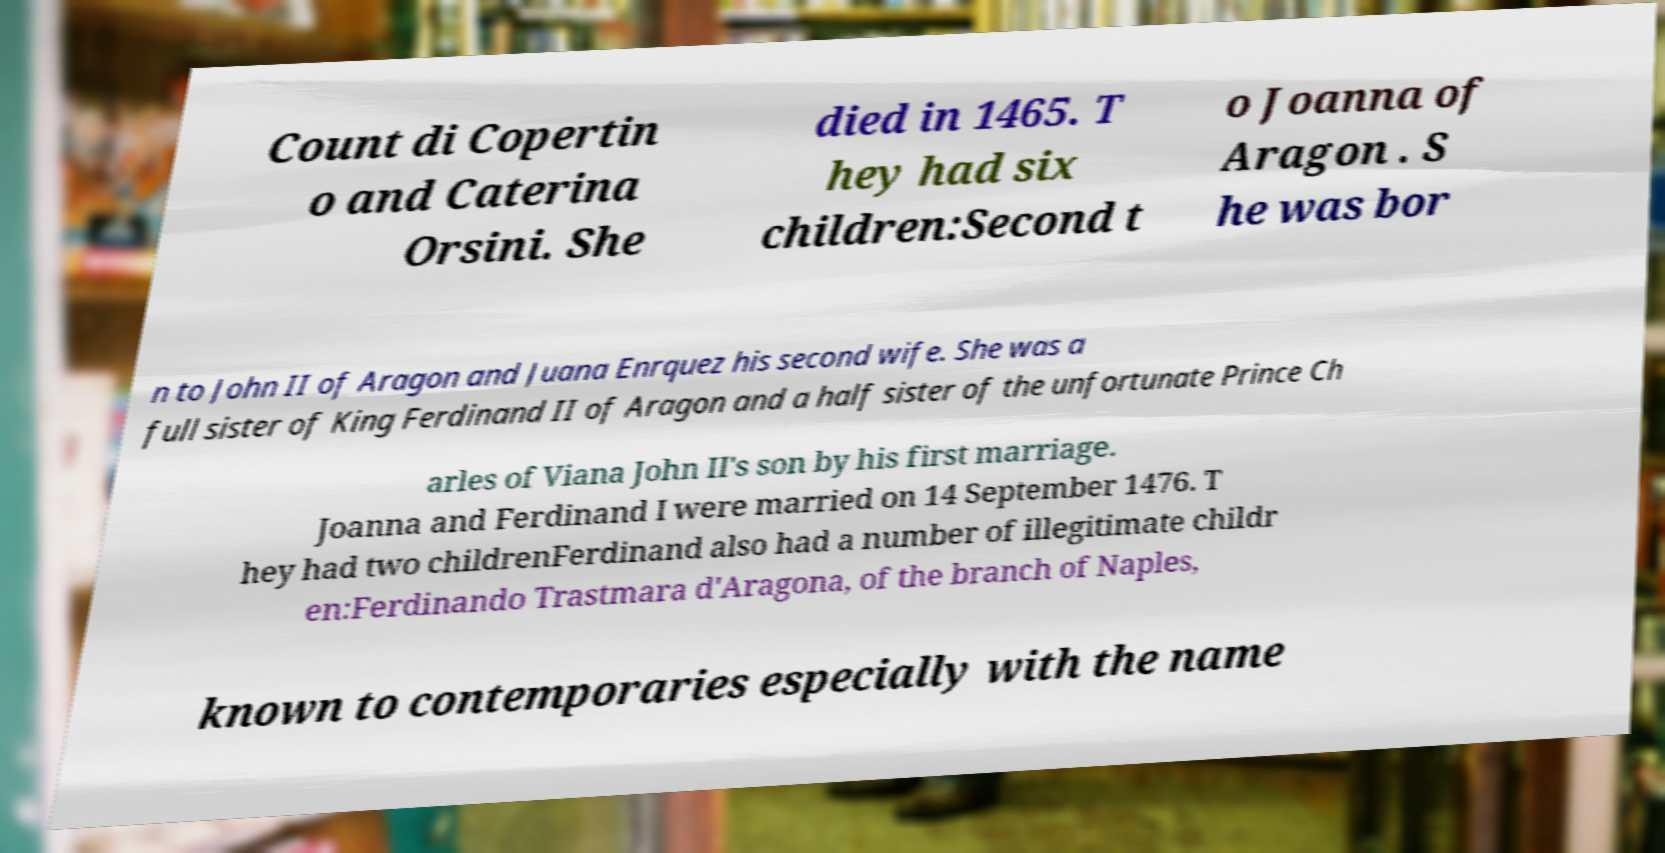What messages or text are displayed in this image? I need them in a readable, typed format. Count di Copertin o and Caterina Orsini. She died in 1465. T hey had six children:Second t o Joanna of Aragon . S he was bor n to John II of Aragon and Juana Enrquez his second wife. She was a full sister of King Ferdinand II of Aragon and a half sister of the unfortunate Prince Ch arles of Viana John II's son by his first marriage. Joanna and Ferdinand I were married on 14 September 1476. T hey had two childrenFerdinand also had a number of illegitimate childr en:Ferdinando Trastmara d'Aragona, of the branch of Naples, known to contemporaries especially with the name 